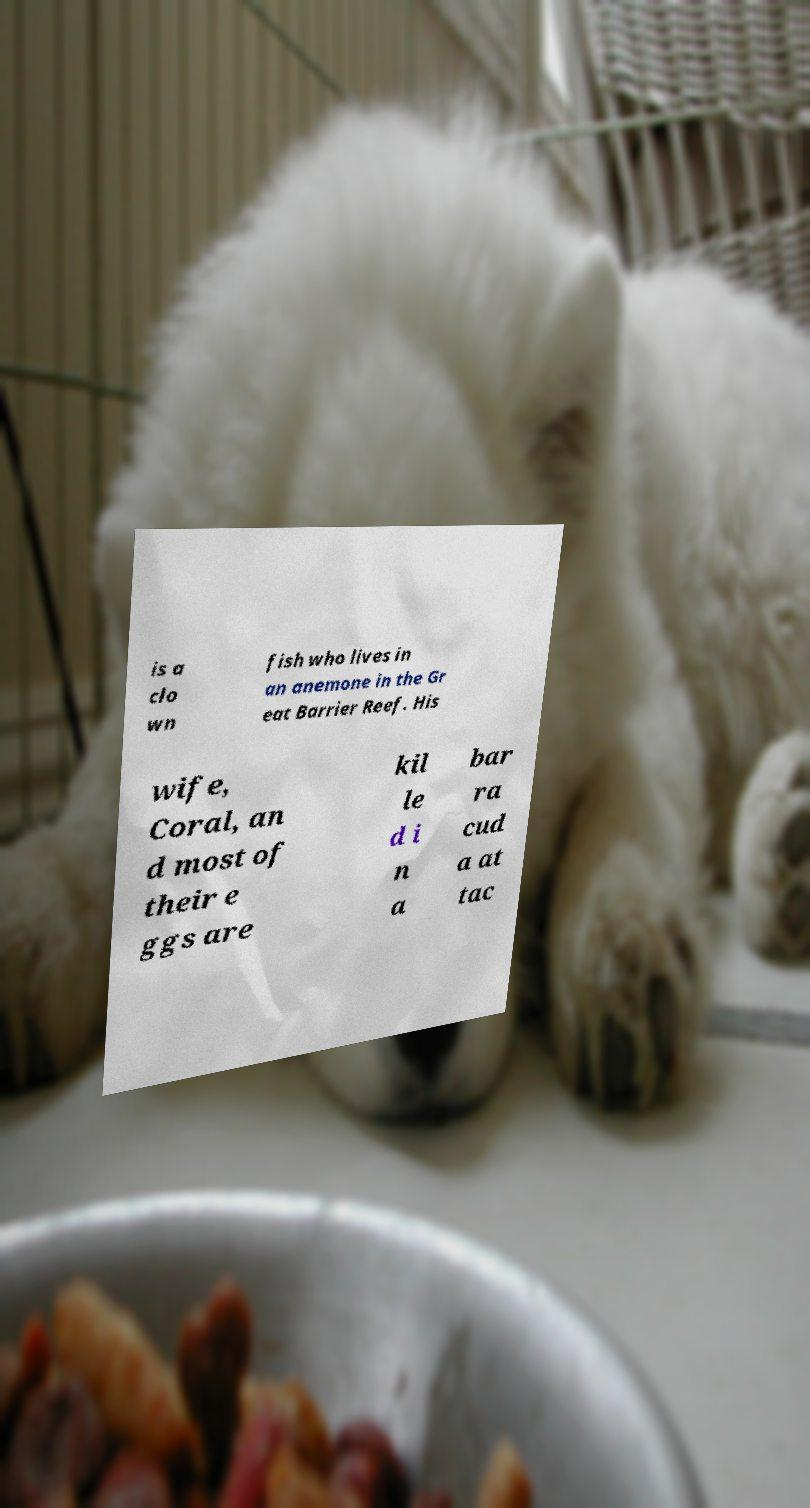I need the written content from this picture converted into text. Can you do that? is a clo wn fish who lives in an anemone in the Gr eat Barrier Reef. His wife, Coral, an d most of their e ggs are kil le d i n a bar ra cud a at tac 